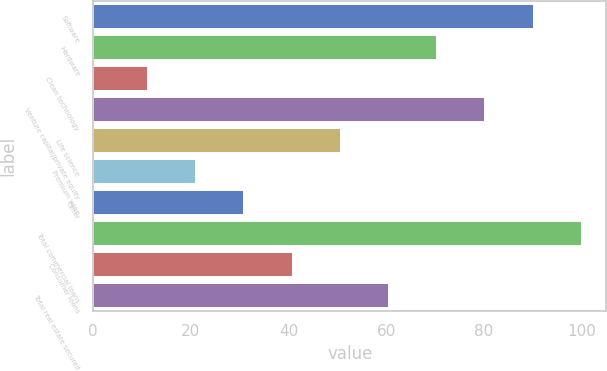Convert chart to OTSL. <chart><loc_0><loc_0><loc_500><loc_500><bar_chart><fcel>Software<fcel>Hardware<fcel>Clean technology<fcel>Venture capital/private equity<fcel>Life science<fcel>Premium wine<fcel>Other<fcel>Total commercial loans<fcel>Consumer loans<fcel>Total real estate secured<nl><fcel>90.13<fcel>70.39<fcel>11.17<fcel>80.26<fcel>50.65<fcel>21.04<fcel>30.91<fcel>100<fcel>40.78<fcel>60.52<nl></chart> 